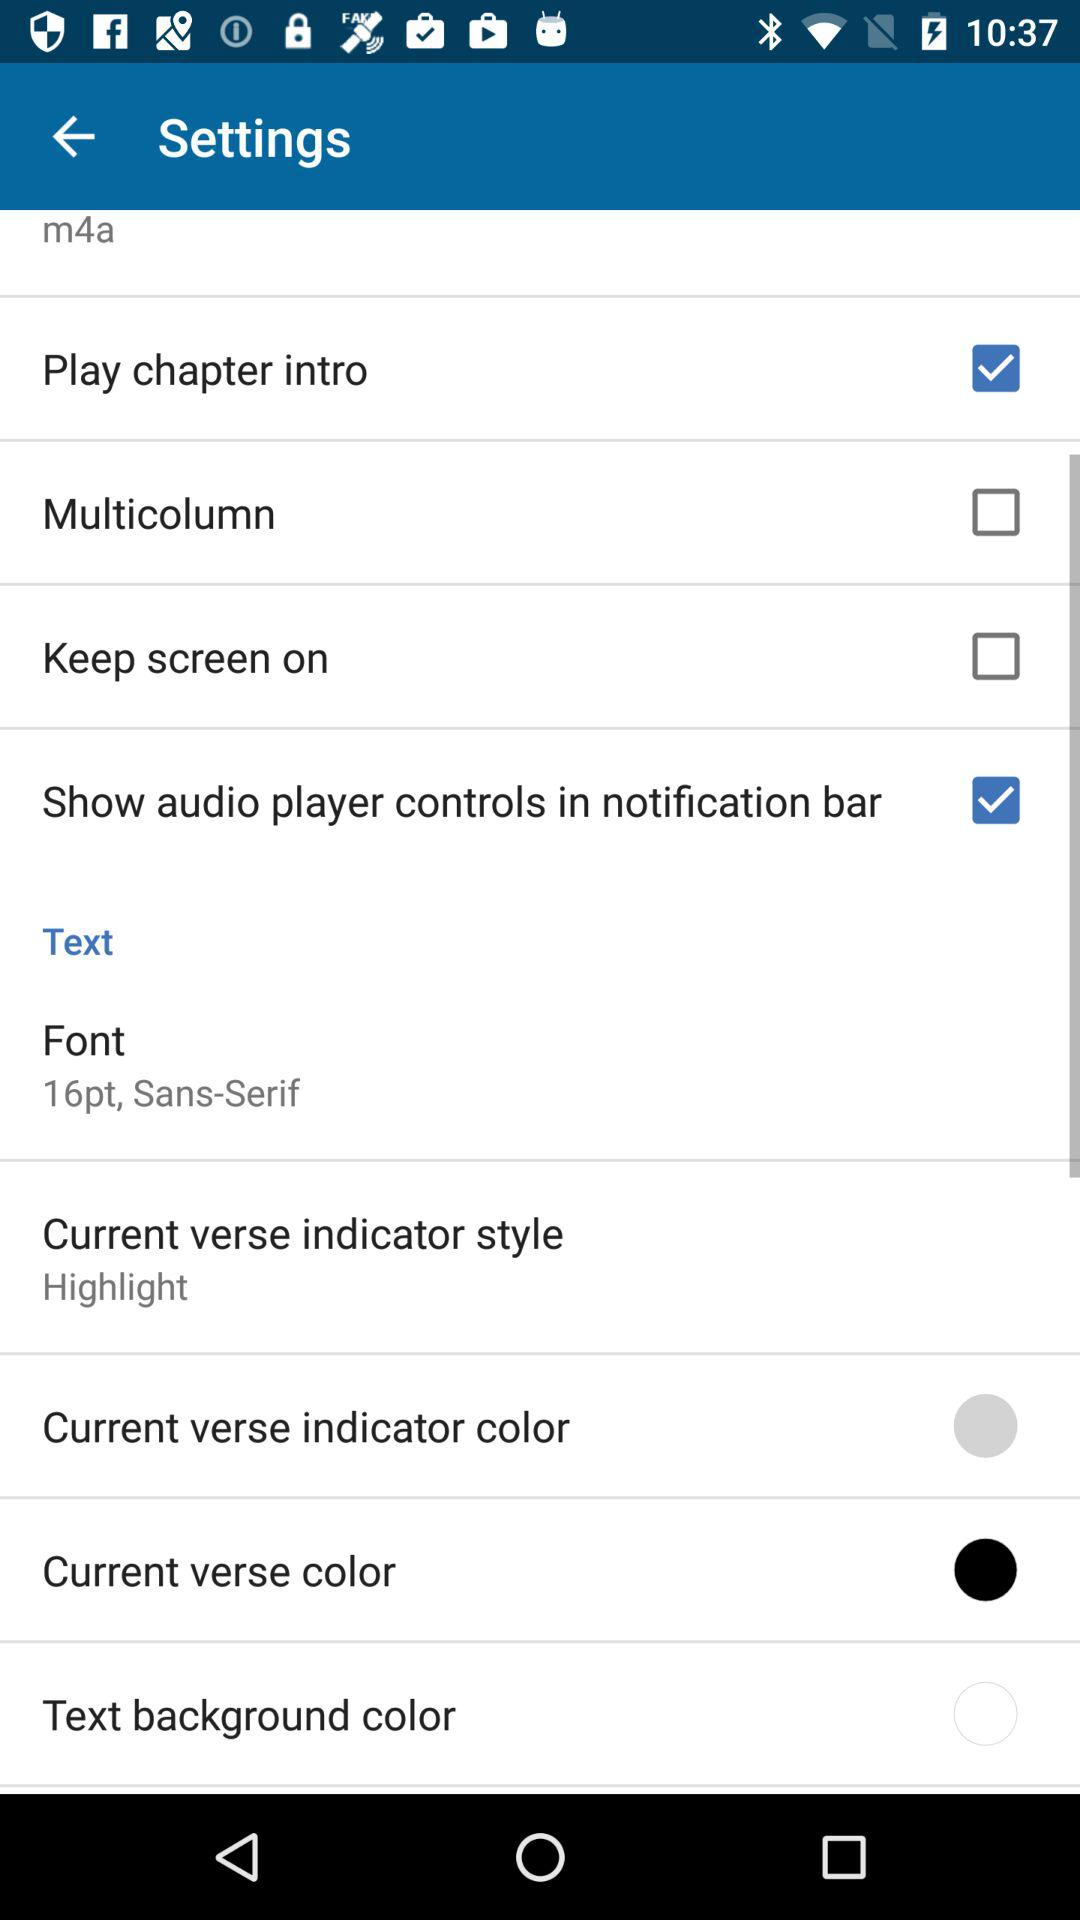What is the status of "keep screen on"? The status of "keep screen on" is off. 